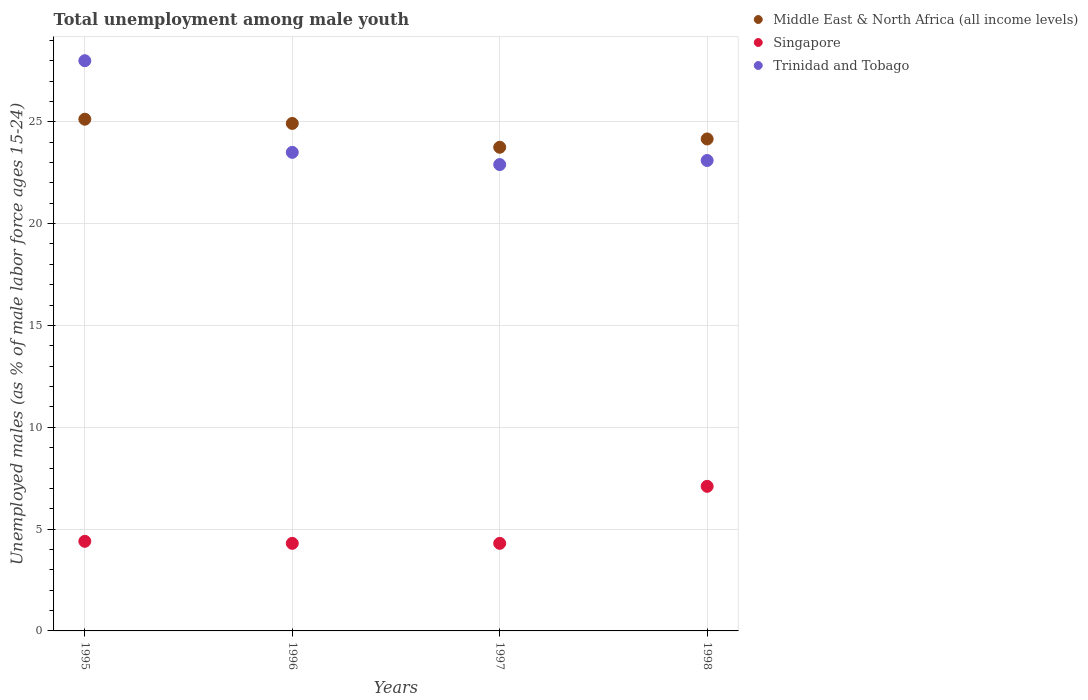Is the number of dotlines equal to the number of legend labels?
Your answer should be very brief. Yes. What is the percentage of unemployed males in in Trinidad and Tobago in 1997?
Offer a very short reply. 22.9. Across all years, what is the maximum percentage of unemployed males in in Trinidad and Tobago?
Your answer should be compact. 28. Across all years, what is the minimum percentage of unemployed males in in Middle East & North Africa (all income levels)?
Offer a very short reply. 23.75. What is the total percentage of unemployed males in in Middle East & North Africa (all income levels) in the graph?
Provide a succinct answer. 97.95. What is the difference between the percentage of unemployed males in in Middle East & North Africa (all income levels) in 1995 and that in 1996?
Make the answer very short. 0.21. What is the difference between the percentage of unemployed males in in Singapore in 1998 and the percentage of unemployed males in in Middle East & North Africa (all income levels) in 1995?
Your response must be concise. -18.03. What is the average percentage of unemployed males in in Trinidad and Tobago per year?
Ensure brevity in your answer.  24.38. In the year 1995, what is the difference between the percentage of unemployed males in in Singapore and percentage of unemployed males in in Trinidad and Tobago?
Keep it short and to the point. -23.6. In how many years, is the percentage of unemployed males in in Singapore greater than 25 %?
Give a very brief answer. 0. What is the difference between the highest and the second highest percentage of unemployed males in in Trinidad and Tobago?
Make the answer very short. 4.5. What is the difference between the highest and the lowest percentage of unemployed males in in Trinidad and Tobago?
Your answer should be compact. 5.1. Does the percentage of unemployed males in in Middle East & North Africa (all income levels) monotonically increase over the years?
Provide a short and direct response. No. Does the graph contain any zero values?
Offer a terse response. No. Does the graph contain grids?
Provide a succinct answer. Yes. Where does the legend appear in the graph?
Provide a short and direct response. Top right. How many legend labels are there?
Give a very brief answer. 3. What is the title of the graph?
Offer a very short reply. Total unemployment among male youth. Does "Micronesia" appear as one of the legend labels in the graph?
Your response must be concise. No. What is the label or title of the X-axis?
Make the answer very short. Years. What is the label or title of the Y-axis?
Keep it short and to the point. Unemployed males (as % of male labor force ages 15-24). What is the Unemployed males (as % of male labor force ages 15-24) of Middle East & North Africa (all income levels) in 1995?
Keep it short and to the point. 25.13. What is the Unemployed males (as % of male labor force ages 15-24) of Singapore in 1995?
Offer a terse response. 4.4. What is the Unemployed males (as % of male labor force ages 15-24) of Trinidad and Tobago in 1995?
Provide a short and direct response. 28. What is the Unemployed males (as % of male labor force ages 15-24) in Middle East & North Africa (all income levels) in 1996?
Give a very brief answer. 24.92. What is the Unemployed males (as % of male labor force ages 15-24) of Singapore in 1996?
Provide a succinct answer. 4.3. What is the Unemployed males (as % of male labor force ages 15-24) of Trinidad and Tobago in 1996?
Your answer should be very brief. 23.5. What is the Unemployed males (as % of male labor force ages 15-24) in Middle East & North Africa (all income levels) in 1997?
Your answer should be compact. 23.75. What is the Unemployed males (as % of male labor force ages 15-24) in Singapore in 1997?
Give a very brief answer. 4.3. What is the Unemployed males (as % of male labor force ages 15-24) in Trinidad and Tobago in 1997?
Make the answer very short. 22.9. What is the Unemployed males (as % of male labor force ages 15-24) of Middle East & North Africa (all income levels) in 1998?
Provide a short and direct response. 24.16. What is the Unemployed males (as % of male labor force ages 15-24) in Singapore in 1998?
Give a very brief answer. 7.1. What is the Unemployed males (as % of male labor force ages 15-24) of Trinidad and Tobago in 1998?
Offer a very short reply. 23.1. Across all years, what is the maximum Unemployed males (as % of male labor force ages 15-24) in Middle East & North Africa (all income levels)?
Provide a short and direct response. 25.13. Across all years, what is the maximum Unemployed males (as % of male labor force ages 15-24) in Singapore?
Your answer should be compact. 7.1. Across all years, what is the minimum Unemployed males (as % of male labor force ages 15-24) of Middle East & North Africa (all income levels)?
Ensure brevity in your answer.  23.75. Across all years, what is the minimum Unemployed males (as % of male labor force ages 15-24) in Singapore?
Offer a very short reply. 4.3. Across all years, what is the minimum Unemployed males (as % of male labor force ages 15-24) in Trinidad and Tobago?
Keep it short and to the point. 22.9. What is the total Unemployed males (as % of male labor force ages 15-24) in Middle East & North Africa (all income levels) in the graph?
Your response must be concise. 97.95. What is the total Unemployed males (as % of male labor force ages 15-24) of Singapore in the graph?
Provide a succinct answer. 20.1. What is the total Unemployed males (as % of male labor force ages 15-24) of Trinidad and Tobago in the graph?
Provide a succinct answer. 97.5. What is the difference between the Unemployed males (as % of male labor force ages 15-24) in Middle East & North Africa (all income levels) in 1995 and that in 1996?
Offer a terse response. 0.21. What is the difference between the Unemployed males (as % of male labor force ages 15-24) of Trinidad and Tobago in 1995 and that in 1996?
Your response must be concise. 4.5. What is the difference between the Unemployed males (as % of male labor force ages 15-24) of Middle East & North Africa (all income levels) in 1995 and that in 1997?
Make the answer very short. 1.38. What is the difference between the Unemployed males (as % of male labor force ages 15-24) of Singapore in 1995 and that in 1997?
Your response must be concise. 0.1. What is the difference between the Unemployed males (as % of male labor force ages 15-24) of Trinidad and Tobago in 1995 and that in 1997?
Provide a short and direct response. 5.1. What is the difference between the Unemployed males (as % of male labor force ages 15-24) in Middle East & North Africa (all income levels) in 1995 and that in 1998?
Keep it short and to the point. 0.97. What is the difference between the Unemployed males (as % of male labor force ages 15-24) in Middle East & North Africa (all income levels) in 1996 and that in 1997?
Provide a succinct answer. 1.17. What is the difference between the Unemployed males (as % of male labor force ages 15-24) of Singapore in 1996 and that in 1997?
Make the answer very short. 0. What is the difference between the Unemployed males (as % of male labor force ages 15-24) of Trinidad and Tobago in 1996 and that in 1997?
Offer a very short reply. 0.6. What is the difference between the Unemployed males (as % of male labor force ages 15-24) of Middle East & North Africa (all income levels) in 1996 and that in 1998?
Keep it short and to the point. 0.76. What is the difference between the Unemployed males (as % of male labor force ages 15-24) in Middle East & North Africa (all income levels) in 1997 and that in 1998?
Your answer should be compact. -0.41. What is the difference between the Unemployed males (as % of male labor force ages 15-24) of Singapore in 1997 and that in 1998?
Give a very brief answer. -2.8. What is the difference between the Unemployed males (as % of male labor force ages 15-24) in Middle East & North Africa (all income levels) in 1995 and the Unemployed males (as % of male labor force ages 15-24) in Singapore in 1996?
Your response must be concise. 20.83. What is the difference between the Unemployed males (as % of male labor force ages 15-24) of Middle East & North Africa (all income levels) in 1995 and the Unemployed males (as % of male labor force ages 15-24) of Trinidad and Tobago in 1996?
Your response must be concise. 1.63. What is the difference between the Unemployed males (as % of male labor force ages 15-24) of Singapore in 1995 and the Unemployed males (as % of male labor force ages 15-24) of Trinidad and Tobago in 1996?
Provide a succinct answer. -19.1. What is the difference between the Unemployed males (as % of male labor force ages 15-24) of Middle East & North Africa (all income levels) in 1995 and the Unemployed males (as % of male labor force ages 15-24) of Singapore in 1997?
Your answer should be very brief. 20.83. What is the difference between the Unemployed males (as % of male labor force ages 15-24) in Middle East & North Africa (all income levels) in 1995 and the Unemployed males (as % of male labor force ages 15-24) in Trinidad and Tobago in 1997?
Your answer should be very brief. 2.23. What is the difference between the Unemployed males (as % of male labor force ages 15-24) in Singapore in 1995 and the Unemployed males (as % of male labor force ages 15-24) in Trinidad and Tobago in 1997?
Your answer should be compact. -18.5. What is the difference between the Unemployed males (as % of male labor force ages 15-24) of Middle East & North Africa (all income levels) in 1995 and the Unemployed males (as % of male labor force ages 15-24) of Singapore in 1998?
Offer a very short reply. 18.03. What is the difference between the Unemployed males (as % of male labor force ages 15-24) in Middle East & North Africa (all income levels) in 1995 and the Unemployed males (as % of male labor force ages 15-24) in Trinidad and Tobago in 1998?
Give a very brief answer. 2.03. What is the difference between the Unemployed males (as % of male labor force ages 15-24) in Singapore in 1995 and the Unemployed males (as % of male labor force ages 15-24) in Trinidad and Tobago in 1998?
Offer a terse response. -18.7. What is the difference between the Unemployed males (as % of male labor force ages 15-24) of Middle East & North Africa (all income levels) in 1996 and the Unemployed males (as % of male labor force ages 15-24) of Singapore in 1997?
Offer a very short reply. 20.62. What is the difference between the Unemployed males (as % of male labor force ages 15-24) in Middle East & North Africa (all income levels) in 1996 and the Unemployed males (as % of male labor force ages 15-24) in Trinidad and Tobago in 1997?
Provide a short and direct response. 2.02. What is the difference between the Unemployed males (as % of male labor force ages 15-24) of Singapore in 1996 and the Unemployed males (as % of male labor force ages 15-24) of Trinidad and Tobago in 1997?
Offer a terse response. -18.6. What is the difference between the Unemployed males (as % of male labor force ages 15-24) in Middle East & North Africa (all income levels) in 1996 and the Unemployed males (as % of male labor force ages 15-24) in Singapore in 1998?
Ensure brevity in your answer.  17.82. What is the difference between the Unemployed males (as % of male labor force ages 15-24) of Middle East & North Africa (all income levels) in 1996 and the Unemployed males (as % of male labor force ages 15-24) of Trinidad and Tobago in 1998?
Give a very brief answer. 1.82. What is the difference between the Unemployed males (as % of male labor force ages 15-24) of Singapore in 1996 and the Unemployed males (as % of male labor force ages 15-24) of Trinidad and Tobago in 1998?
Make the answer very short. -18.8. What is the difference between the Unemployed males (as % of male labor force ages 15-24) in Middle East & North Africa (all income levels) in 1997 and the Unemployed males (as % of male labor force ages 15-24) in Singapore in 1998?
Ensure brevity in your answer.  16.65. What is the difference between the Unemployed males (as % of male labor force ages 15-24) in Middle East & North Africa (all income levels) in 1997 and the Unemployed males (as % of male labor force ages 15-24) in Trinidad and Tobago in 1998?
Ensure brevity in your answer.  0.65. What is the difference between the Unemployed males (as % of male labor force ages 15-24) in Singapore in 1997 and the Unemployed males (as % of male labor force ages 15-24) in Trinidad and Tobago in 1998?
Keep it short and to the point. -18.8. What is the average Unemployed males (as % of male labor force ages 15-24) of Middle East & North Africa (all income levels) per year?
Offer a very short reply. 24.49. What is the average Unemployed males (as % of male labor force ages 15-24) of Singapore per year?
Your response must be concise. 5.03. What is the average Unemployed males (as % of male labor force ages 15-24) of Trinidad and Tobago per year?
Your response must be concise. 24.38. In the year 1995, what is the difference between the Unemployed males (as % of male labor force ages 15-24) in Middle East & North Africa (all income levels) and Unemployed males (as % of male labor force ages 15-24) in Singapore?
Your response must be concise. 20.73. In the year 1995, what is the difference between the Unemployed males (as % of male labor force ages 15-24) in Middle East & North Africa (all income levels) and Unemployed males (as % of male labor force ages 15-24) in Trinidad and Tobago?
Offer a terse response. -2.87. In the year 1995, what is the difference between the Unemployed males (as % of male labor force ages 15-24) in Singapore and Unemployed males (as % of male labor force ages 15-24) in Trinidad and Tobago?
Your answer should be compact. -23.6. In the year 1996, what is the difference between the Unemployed males (as % of male labor force ages 15-24) of Middle East & North Africa (all income levels) and Unemployed males (as % of male labor force ages 15-24) of Singapore?
Your response must be concise. 20.62. In the year 1996, what is the difference between the Unemployed males (as % of male labor force ages 15-24) of Middle East & North Africa (all income levels) and Unemployed males (as % of male labor force ages 15-24) of Trinidad and Tobago?
Your answer should be very brief. 1.42. In the year 1996, what is the difference between the Unemployed males (as % of male labor force ages 15-24) of Singapore and Unemployed males (as % of male labor force ages 15-24) of Trinidad and Tobago?
Your answer should be very brief. -19.2. In the year 1997, what is the difference between the Unemployed males (as % of male labor force ages 15-24) in Middle East & North Africa (all income levels) and Unemployed males (as % of male labor force ages 15-24) in Singapore?
Offer a terse response. 19.45. In the year 1997, what is the difference between the Unemployed males (as % of male labor force ages 15-24) of Middle East & North Africa (all income levels) and Unemployed males (as % of male labor force ages 15-24) of Trinidad and Tobago?
Offer a very short reply. 0.85. In the year 1997, what is the difference between the Unemployed males (as % of male labor force ages 15-24) in Singapore and Unemployed males (as % of male labor force ages 15-24) in Trinidad and Tobago?
Your answer should be compact. -18.6. In the year 1998, what is the difference between the Unemployed males (as % of male labor force ages 15-24) in Middle East & North Africa (all income levels) and Unemployed males (as % of male labor force ages 15-24) in Singapore?
Offer a very short reply. 17.06. In the year 1998, what is the difference between the Unemployed males (as % of male labor force ages 15-24) of Middle East & North Africa (all income levels) and Unemployed males (as % of male labor force ages 15-24) of Trinidad and Tobago?
Provide a succinct answer. 1.06. What is the ratio of the Unemployed males (as % of male labor force ages 15-24) in Middle East & North Africa (all income levels) in 1995 to that in 1996?
Give a very brief answer. 1.01. What is the ratio of the Unemployed males (as % of male labor force ages 15-24) in Singapore in 1995 to that in 1996?
Ensure brevity in your answer.  1.02. What is the ratio of the Unemployed males (as % of male labor force ages 15-24) in Trinidad and Tobago in 1995 to that in 1996?
Give a very brief answer. 1.19. What is the ratio of the Unemployed males (as % of male labor force ages 15-24) of Middle East & North Africa (all income levels) in 1995 to that in 1997?
Your answer should be compact. 1.06. What is the ratio of the Unemployed males (as % of male labor force ages 15-24) in Singapore in 1995 to that in 1997?
Offer a very short reply. 1.02. What is the ratio of the Unemployed males (as % of male labor force ages 15-24) of Trinidad and Tobago in 1995 to that in 1997?
Your answer should be compact. 1.22. What is the ratio of the Unemployed males (as % of male labor force ages 15-24) in Middle East & North Africa (all income levels) in 1995 to that in 1998?
Keep it short and to the point. 1.04. What is the ratio of the Unemployed males (as % of male labor force ages 15-24) in Singapore in 1995 to that in 1998?
Offer a very short reply. 0.62. What is the ratio of the Unemployed males (as % of male labor force ages 15-24) in Trinidad and Tobago in 1995 to that in 1998?
Offer a very short reply. 1.21. What is the ratio of the Unemployed males (as % of male labor force ages 15-24) in Middle East & North Africa (all income levels) in 1996 to that in 1997?
Your answer should be very brief. 1.05. What is the ratio of the Unemployed males (as % of male labor force ages 15-24) in Trinidad and Tobago in 1996 to that in 1997?
Your answer should be very brief. 1.03. What is the ratio of the Unemployed males (as % of male labor force ages 15-24) in Middle East & North Africa (all income levels) in 1996 to that in 1998?
Give a very brief answer. 1.03. What is the ratio of the Unemployed males (as % of male labor force ages 15-24) of Singapore in 1996 to that in 1998?
Keep it short and to the point. 0.61. What is the ratio of the Unemployed males (as % of male labor force ages 15-24) of Trinidad and Tobago in 1996 to that in 1998?
Your answer should be compact. 1.02. What is the ratio of the Unemployed males (as % of male labor force ages 15-24) of Middle East & North Africa (all income levels) in 1997 to that in 1998?
Ensure brevity in your answer.  0.98. What is the ratio of the Unemployed males (as % of male labor force ages 15-24) of Singapore in 1997 to that in 1998?
Your answer should be compact. 0.61. What is the difference between the highest and the second highest Unemployed males (as % of male labor force ages 15-24) of Middle East & North Africa (all income levels)?
Give a very brief answer. 0.21. What is the difference between the highest and the lowest Unemployed males (as % of male labor force ages 15-24) in Middle East & North Africa (all income levels)?
Offer a very short reply. 1.38. 